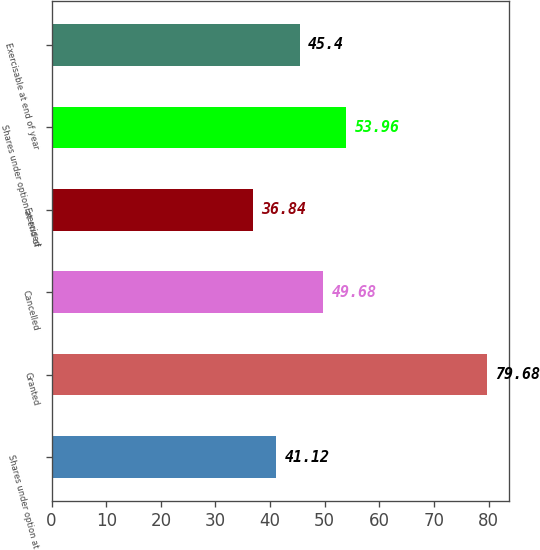Convert chart. <chart><loc_0><loc_0><loc_500><loc_500><bar_chart><fcel>Shares under option at<fcel>Granted<fcel>Cancelled<fcel>Exercised<fcel>Shares under option at end of<fcel>Exercisable at end of year<nl><fcel>41.12<fcel>79.68<fcel>49.68<fcel>36.84<fcel>53.96<fcel>45.4<nl></chart> 